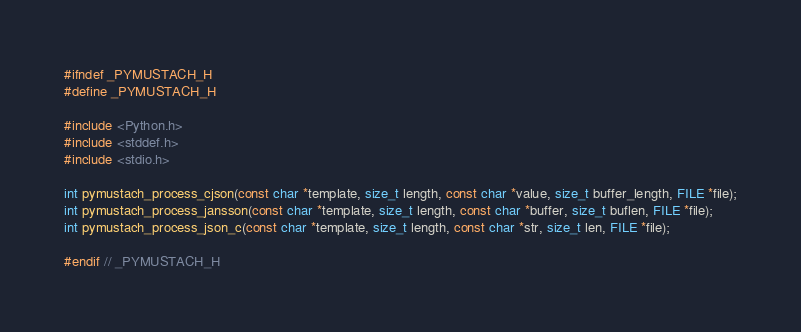Convert code to text. <code><loc_0><loc_0><loc_500><loc_500><_C_>#ifndef _PYMUSTACH_H
#define _PYMUSTACH_H

#include <Python.h>
#include <stddef.h>
#include <stdio.h>

int pymustach_process_cjson(const char *template, size_t length, const char *value, size_t buffer_length, FILE *file);
int pymustach_process_jansson(const char *template, size_t length, const char *buffer, size_t buflen, FILE *file);
int pymustach_process_json_c(const char *template, size_t length, const char *str, size_t len, FILE *file);

#endif // _PYMUSTACH_H
</code> 